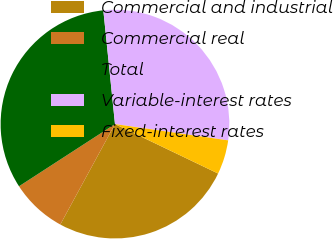Convert chart to OTSL. <chart><loc_0><loc_0><loc_500><loc_500><pie_chart><fcel>Commercial and industrial<fcel>Commercial real<fcel>Total<fcel>Variable-interest rates<fcel>Fixed-interest rates<nl><fcel>25.82%<fcel>7.91%<fcel>32.53%<fcel>28.9%<fcel>4.84%<nl></chart> 